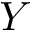<formula> <loc_0><loc_0><loc_500><loc_500>Y</formula> 